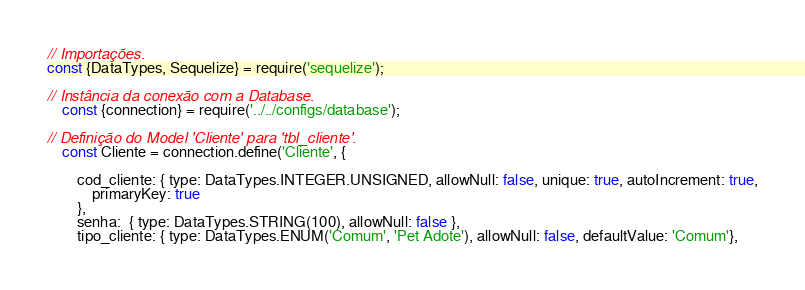<code> <loc_0><loc_0><loc_500><loc_500><_JavaScript_>// Importações.
const {DataTypes, Sequelize} = require('sequelize');

// Instância da conexão com a Database.
    const {connection} = require('../../configs/database');

// Definição do Model 'Cliente' para 'tbl_cliente'.
    const Cliente = connection.define('Cliente', {

        cod_cliente: { type: DataTypes.INTEGER.UNSIGNED, allowNull: false, unique: true, autoIncrement: true,
            primaryKey: true
        },
        senha:  { type: DataTypes.STRING(100), allowNull: false },
        tipo_cliente: { type: DataTypes.ENUM('Comum', 'Pet Adote'), allowNull: false, defaultValue: 'Comum'},</code> 